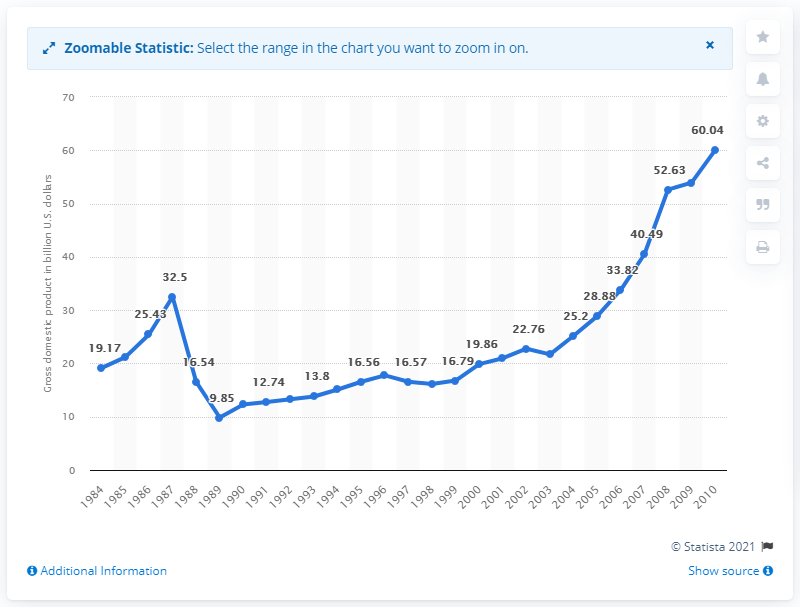Identify some key points in this picture. In 2010, Syria's gross domestic product was 60.04. 